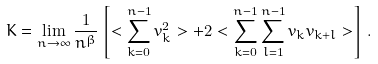<formula> <loc_0><loc_0><loc_500><loc_500>K = \lim _ { n \rightarrow \infty } \frac { 1 } { n ^ { \beta } } \left [ < \sum _ { k = 0 } ^ { n - 1 } v _ { k } ^ { 2 } > + 2 < \sum _ { k = 0 } ^ { n - 1 } \sum _ { l = 1 } ^ { n - 1 } v _ { k } v _ { k + l } > \right ] \, .</formula> 